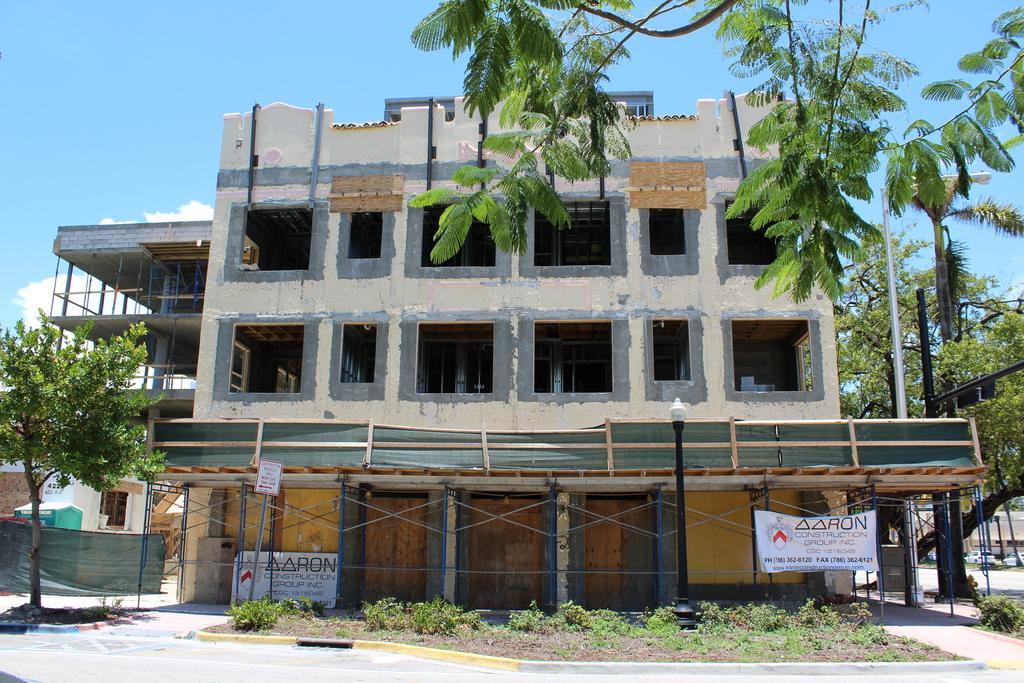In one or two sentences, can you explain what this image depicts? In this picture we can see constructing building, trees and vehicle. 